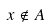<formula> <loc_0><loc_0><loc_500><loc_500>x \notin A</formula> 